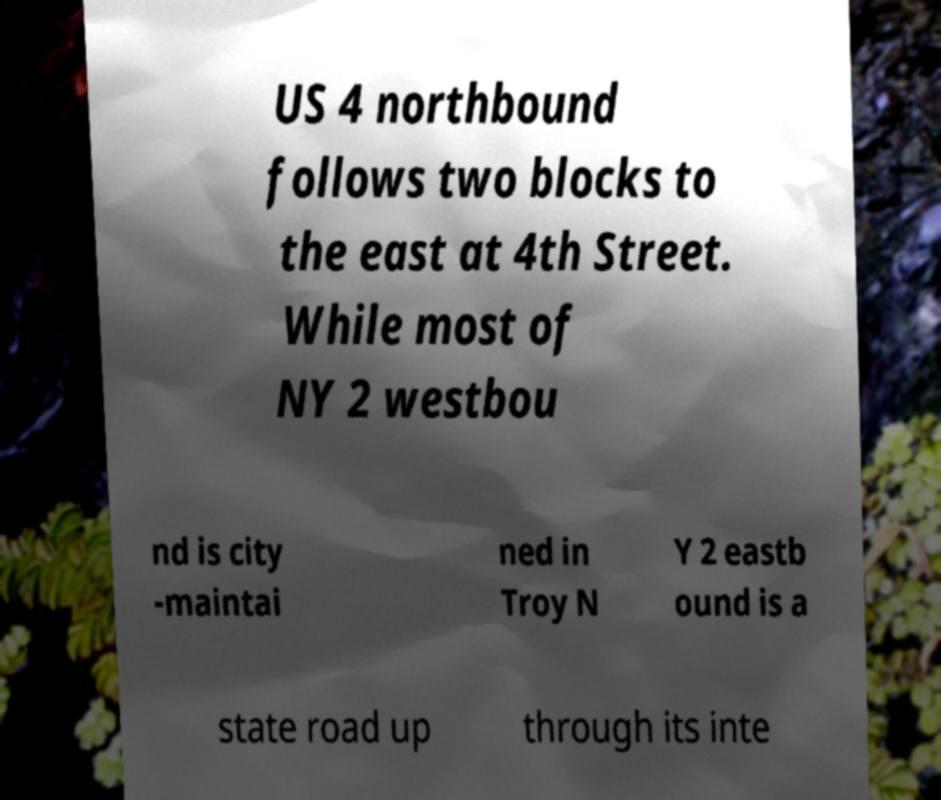For documentation purposes, I need the text within this image transcribed. Could you provide that? US 4 northbound follows two blocks to the east at 4th Street. While most of NY 2 westbou nd is city -maintai ned in Troy N Y 2 eastb ound is a state road up through its inte 